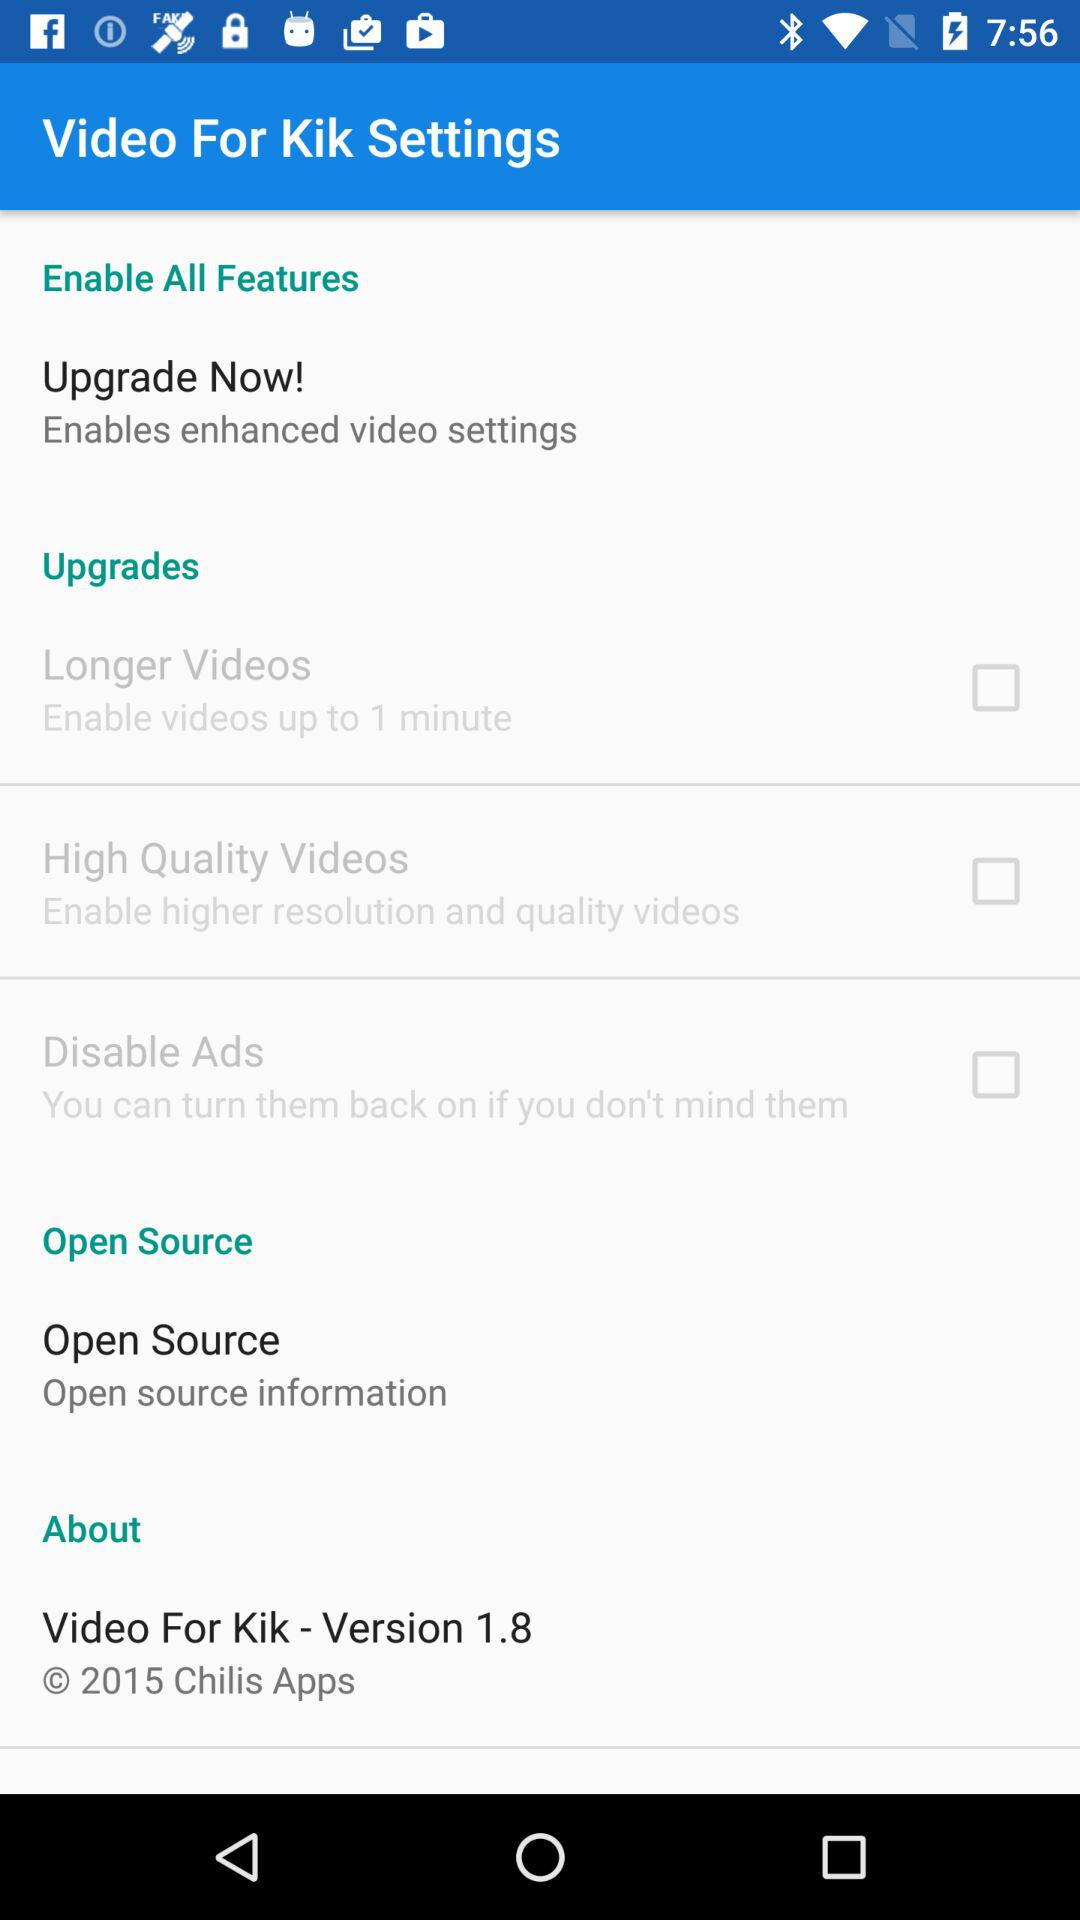How many items are in the 'Upgrades' section?
Answer the question using a single word or phrase. 3 